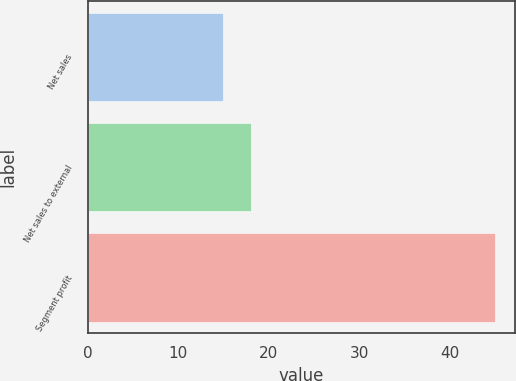Convert chart. <chart><loc_0><loc_0><loc_500><loc_500><bar_chart><fcel>Net sales<fcel>Net sales to external<fcel>Segment profit<nl><fcel>15<fcel>18<fcel>45<nl></chart> 